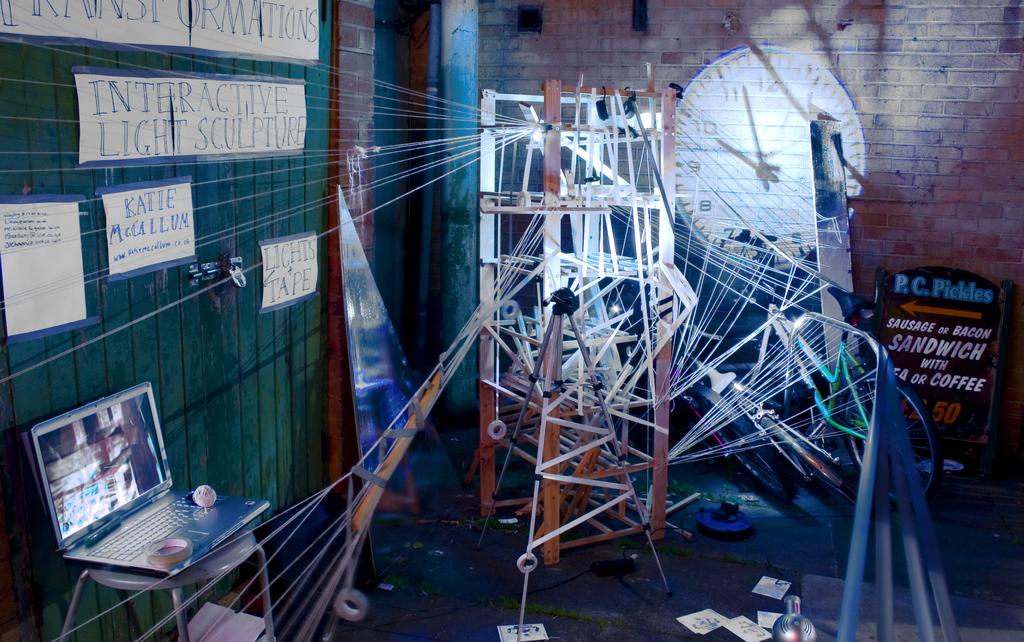What time does the clock say?
Give a very brief answer. 9:57. What is the price of the sandwich on the board?
Provide a short and direct response. 2.50. 